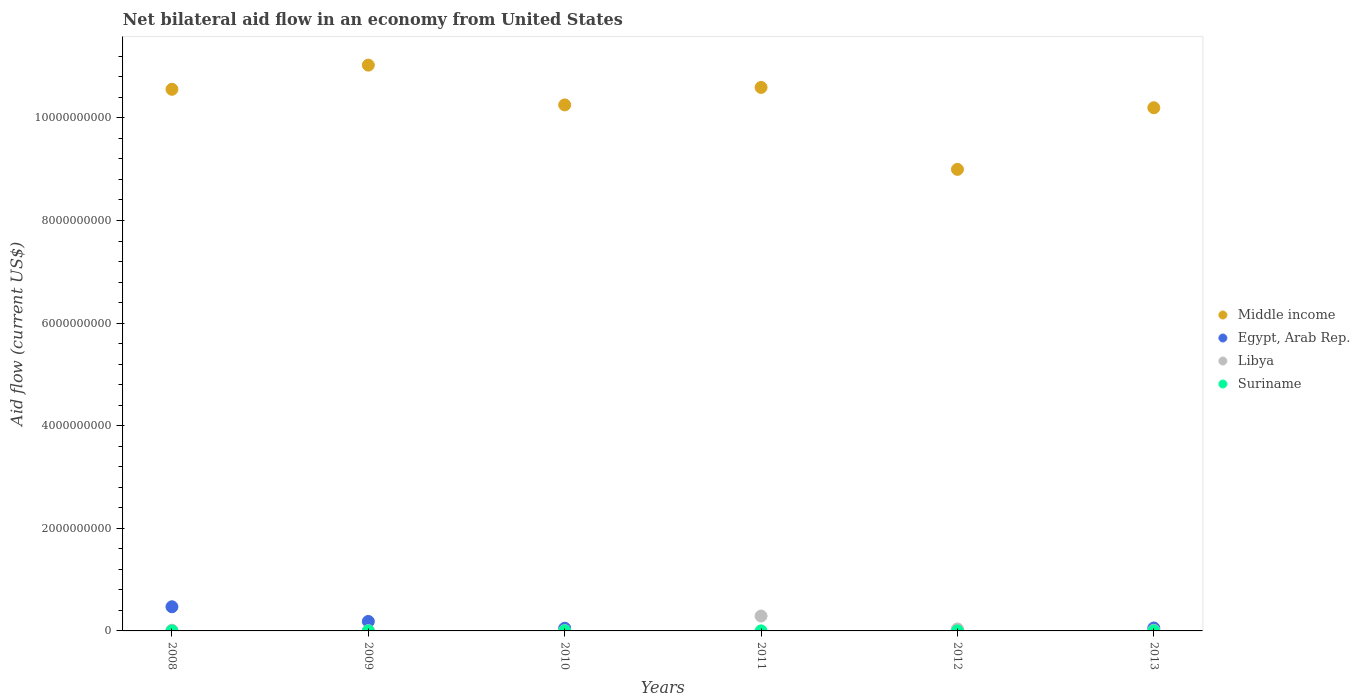How many different coloured dotlines are there?
Offer a very short reply. 4. What is the net bilateral aid flow in Libya in 2010?
Your response must be concise. 6.60e+06. Across all years, what is the maximum net bilateral aid flow in Libya?
Ensure brevity in your answer.  2.90e+08. Across all years, what is the minimum net bilateral aid flow in Libya?
Offer a terse response. 5.65e+06. In which year was the net bilateral aid flow in Middle income maximum?
Your answer should be compact. 2009. What is the total net bilateral aid flow in Suriname in the graph?
Provide a short and direct response. 1.89e+06. What is the difference between the net bilateral aid flow in Libya in 2008 and the net bilateral aid flow in Suriname in 2010?
Offer a terse response. 1.40e+07. What is the average net bilateral aid flow in Egypt, Arab Rep. per year?
Your response must be concise. 1.28e+08. In the year 2010, what is the difference between the net bilateral aid flow in Suriname and net bilateral aid flow in Middle income?
Offer a very short reply. -1.03e+1. In how many years, is the net bilateral aid flow in Suriname greater than 8000000000 US$?
Ensure brevity in your answer.  0. What is the ratio of the net bilateral aid flow in Egypt, Arab Rep. in 2010 to that in 2013?
Make the answer very short. 0.92. What is the difference between the highest and the second highest net bilateral aid flow in Middle income?
Provide a short and direct response. 4.35e+08. What is the difference between the highest and the lowest net bilateral aid flow in Libya?
Ensure brevity in your answer.  2.85e+08. Is it the case that in every year, the sum of the net bilateral aid flow in Libya and net bilateral aid flow in Egypt, Arab Rep.  is greater than the sum of net bilateral aid flow in Suriname and net bilateral aid flow in Middle income?
Offer a very short reply. No. Is it the case that in every year, the sum of the net bilateral aid flow in Suriname and net bilateral aid flow in Egypt, Arab Rep.  is greater than the net bilateral aid flow in Libya?
Offer a very short reply. No. Does the net bilateral aid flow in Suriname monotonically increase over the years?
Offer a terse response. No. Is the net bilateral aid flow in Suriname strictly less than the net bilateral aid flow in Middle income over the years?
Your answer should be very brief. Yes. What is the difference between two consecutive major ticks on the Y-axis?
Keep it short and to the point. 2.00e+09. Are the values on the major ticks of Y-axis written in scientific E-notation?
Make the answer very short. No. Does the graph contain any zero values?
Keep it short and to the point. Yes. Does the graph contain grids?
Make the answer very short. No. Where does the legend appear in the graph?
Your response must be concise. Center right. How are the legend labels stacked?
Make the answer very short. Vertical. What is the title of the graph?
Keep it short and to the point. Net bilateral aid flow in an economy from United States. Does "Middle East & North Africa (developing only)" appear as one of the legend labels in the graph?
Ensure brevity in your answer.  No. What is the label or title of the X-axis?
Provide a short and direct response. Years. What is the label or title of the Y-axis?
Provide a succinct answer. Aid flow (current US$). What is the Aid flow (current US$) in Middle income in 2008?
Offer a very short reply. 1.06e+1. What is the Aid flow (current US$) in Egypt, Arab Rep. in 2008?
Provide a succinct answer. 4.71e+08. What is the Aid flow (current US$) in Libya in 2008?
Provide a succinct answer. 1.43e+07. What is the Aid flow (current US$) of Middle income in 2009?
Your response must be concise. 1.10e+1. What is the Aid flow (current US$) of Egypt, Arab Rep. in 2009?
Provide a short and direct response. 1.85e+08. What is the Aid flow (current US$) of Libya in 2009?
Your answer should be very brief. 5.65e+06. What is the Aid flow (current US$) in Suriname in 2009?
Offer a very short reply. 6.40e+05. What is the Aid flow (current US$) of Middle income in 2010?
Make the answer very short. 1.03e+1. What is the Aid flow (current US$) of Egypt, Arab Rep. in 2010?
Provide a succinct answer. 5.27e+07. What is the Aid flow (current US$) of Libya in 2010?
Keep it short and to the point. 6.60e+06. What is the Aid flow (current US$) of Suriname in 2010?
Ensure brevity in your answer.  2.20e+05. What is the Aid flow (current US$) in Middle income in 2011?
Make the answer very short. 1.06e+1. What is the Aid flow (current US$) of Libya in 2011?
Offer a terse response. 2.90e+08. What is the Aid flow (current US$) of Suriname in 2011?
Make the answer very short. 9.70e+05. What is the Aid flow (current US$) in Middle income in 2012?
Give a very brief answer. 9.00e+09. What is the Aid flow (current US$) of Libya in 2012?
Give a very brief answer. 3.85e+07. What is the Aid flow (current US$) in Suriname in 2012?
Ensure brevity in your answer.  6.00e+04. What is the Aid flow (current US$) in Middle income in 2013?
Make the answer very short. 1.02e+1. What is the Aid flow (current US$) of Egypt, Arab Rep. in 2013?
Offer a very short reply. 5.72e+07. What is the Aid flow (current US$) in Libya in 2013?
Your response must be concise. 1.24e+07. Across all years, what is the maximum Aid flow (current US$) of Middle income?
Your response must be concise. 1.10e+1. Across all years, what is the maximum Aid flow (current US$) in Egypt, Arab Rep.?
Give a very brief answer. 4.71e+08. Across all years, what is the maximum Aid flow (current US$) of Libya?
Give a very brief answer. 2.90e+08. Across all years, what is the maximum Aid flow (current US$) in Suriname?
Make the answer very short. 9.70e+05. Across all years, what is the minimum Aid flow (current US$) in Middle income?
Ensure brevity in your answer.  9.00e+09. Across all years, what is the minimum Aid flow (current US$) in Egypt, Arab Rep.?
Your answer should be very brief. 0. Across all years, what is the minimum Aid flow (current US$) in Libya?
Ensure brevity in your answer.  5.65e+06. What is the total Aid flow (current US$) of Middle income in the graph?
Your response must be concise. 6.16e+1. What is the total Aid flow (current US$) in Egypt, Arab Rep. in the graph?
Your answer should be compact. 7.66e+08. What is the total Aid flow (current US$) of Libya in the graph?
Give a very brief answer. 3.68e+08. What is the total Aid flow (current US$) of Suriname in the graph?
Your response must be concise. 1.89e+06. What is the difference between the Aid flow (current US$) of Middle income in 2008 and that in 2009?
Provide a short and direct response. -4.71e+08. What is the difference between the Aid flow (current US$) of Egypt, Arab Rep. in 2008 and that in 2009?
Make the answer very short. 2.86e+08. What is the difference between the Aid flow (current US$) in Libya in 2008 and that in 2009?
Your response must be concise. 8.61e+06. What is the difference between the Aid flow (current US$) in Middle income in 2008 and that in 2010?
Make the answer very short. 3.04e+08. What is the difference between the Aid flow (current US$) of Egypt, Arab Rep. in 2008 and that in 2010?
Make the answer very short. 4.18e+08. What is the difference between the Aid flow (current US$) of Libya in 2008 and that in 2010?
Give a very brief answer. 7.66e+06. What is the difference between the Aid flow (current US$) in Middle income in 2008 and that in 2011?
Keep it short and to the point. -3.65e+07. What is the difference between the Aid flow (current US$) of Libya in 2008 and that in 2011?
Ensure brevity in your answer.  -2.76e+08. What is the difference between the Aid flow (current US$) in Middle income in 2008 and that in 2012?
Make the answer very short. 1.56e+09. What is the difference between the Aid flow (current US$) in Libya in 2008 and that in 2012?
Provide a succinct answer. -2.43e+07. What is the difference between the Aid flow (current US$) of Middle income in 2008 and that in 2013?
Provide a short and direct response. 3.60e+08. What is the difference between the Aid flow (current US$) of Egypt, Arab Rep. in 2008 and that in 2013?
Your response must be concise. 4.14e+08. What is the difference between the Aid flow (current US$) in Libya in 2008 and that in 2013?
Your answer should be very brief. 1.91e+06. What is the difference between the Aid flow (current US$) of Middle income in 2009 and that in 2010?
Keep it short and to the point. 7.76e+08. What is the difference between the Aid flow (current US$) of Egypt, Arab Rep. in 2009 and that in 2010?
Your response must be concise. 1.32e+08. What is the difference between the Aid flow (current US$) in Libya in 2009 and that in 2010?
Give a very brief answer. -9.50e+05. What is the difference between the Aid flow (current US$) in Suriname in 2009 and that in 2010?
Offer a very short reply. 4.20e+05. What is the difference between the Aid flow (current US$) in Middle income in 2009 and that in 2011?
Give a very brief answer. 4.35e+08. What is the difference between the Aid flow (current US$) of Libya in 2009 and that in 2011?
Offer a very short reply. -2.85e+08. What is the difference between the Aid flow (current US$) of Suriname in 2009 and that in 2011?
Ensure brevity in your answer.  -3.30e+05. What is the difference between the Aid flow (current US$) in Middle income in 2009 and that in 2012?
Give a very brief answer. 2.03e+09. What is the difference between the Aid flow (current US$) of Libya in 2009 and that in 2012?
Your answer should be very brief. -3.29e+07. What is the difference between the Aid flow (current US$) in Suriname in 2009 and that in 2012?
Give a very brief answer. 5.80e+05. What is the difference between the Aid flow (current US$) of Middle income in 2009 and that in 2013?
Make the answer very short. 8.31e+08. What is the difference between the Aid flow (current US$) in Egypt, Arab Rep. in 2009 and that in 2013?
Your answer should be very brief. 1.28e+08. What is the difference between the Aid flow (current US$) of Libya in 2009 and that in 2013?
Ensure brevity in your answer.  -6.70e+06. What is the difference between the Aid flow (current US$) of Middle income in 2010 and that in 2011?
Provide a short and direct response. -3.41e+08. What is the difference between the Aid flow (current US$) of Libya in 2010 and that in 2011?
Your answer should be very brief. -2.84e+08. What is the difference between the Aid flow (current US$) of Suriname in 2010 and that in 2011?
Provide a succinct answer. -7.50e+05. What is the difference between the Aid flow (current US$) of Middle income in 2010 and that in 2012?
Keep it short and to the point. 1.26e+09. What is the difference between the Aid flow (current US$) of Libya in 2010 and that in 2012?
Give a very brief answer. -3.19e+07. What is the difference between the Aid flow (current US$) of Suriname in 2010 and that in 2012?
Give a very brief answer. 1.60e+05. What is the difference between the Aid flow (current US$) in Middle income in 2010 and that in 2013?
Make the answer very short. 5.56e+07. What is the difference between the Aid flow (current US$) of Egypt, Arab Rep. in 2010 and that in 2013?
Provide a succinct answer. -4.54e+06. What is the difference between the Aid flow (current US$) in Libya in 2010 and that in 2013?
Offer a terse response. -5.75e+06. What is the difference between the Aid flow (current US$) of Middle income in 2011 and that in 2012?
Your answer should be very brief. 1.60e+09. What is the difference between the Aid flow (current US$) of Libya in 2011 and that in 2012?
Offer a very short reply. 2.52e+08. What is the difference between the Aid flow (current US$) of Suriname in 2011 and that in 2012?
Keep it short and to the point. 9.10e+05. What is the difference between the Aid flow (current US$) in Middle income in 2011 and that in 2013?
Offer a very short reply. 3.96e+08. What is the difference between the Aid flow (current US$) of Libya in 2011 and that in 2013?
Offer a terse response. 2.78e+08. What is the difference between the Aid flow (current US$) of Middle income in 2012 and that in 2013?
Ensure brevity in your answer.  -1.20e+09. What is the difference between the Aid flow (current US$) of Libya in 2012 and that in 2013?
Keep it short and to the point. 2.62e+07. What is the difference between the Aid flow (current US$) in Middle income in 2008 and the Aid flow (current US$) in Egypt, Arab Rep. in 2009?
Offer a terse response. 1.04e+1. What is the difference between the Aid flow (current US$) of Middle income in 2008 and the Aid flow (current US$) of Libya in 2009?
Ensure brevity in your answer.  1.06e+1. What is the difference between the Aid flow (current US$) of Middle income in 2008 and the Aid flow (current US$) of Suriname in 2009?
Offer a terse response. 1.06e+1. What is the difference between the Aid flow (current US$) of Egypt, Arab Rep. in 2008 and the Aid flow (current US$) of Libya in 2009?
Make the answer very short. 4.65e+08. What is the difference between the Aid flow (current US$) of Egypt, Arab Rep. in 2008 and the Aid flow (current US$) of Suriname in 2009?
Make the answer very short. 4.70e+08. What is the difference between the Aid flow (current US$) in Libya in 2008 and the Aid flow (current US$) in Suriname in 2009?
Give a very brief answer. 1.36e+07. What is the difference between the Aid flow (current US$) of Middle income in 2008 and the Aid flow (current US$) of Egypt, Arab Rep. in 2010?
Your answer should be very brief. 1.05e+1. What is the difference between the Aid flow (current US$) in Middle income in 2008 and the Aid flow (current US$) in Libya in 2010?
Provide a short and direct response. 1.06e+1. What is the difference between the Aid flow (current US$) in Middle income in 2008 and the Aid flow (current US$) in Suriname in 2010?
Offer a terse response. 1.06e+1. What is the difference between the Aid flow (current US$) in Egypt, Arab Rep. in 2008 and the Aid flow (current US$) in Libya in 2010?
Make the answer very short. 4.64e+08. What is the difference between the Aid flow (current US$) in Egypt, Arab Rep. in 2008 and the Aid flow (current US$) in Suriname in 2010?
Your answer should be very brief. 4.71e+08. What is the difference between the Aid flow (current US$) of Libya in 2008 and the Aid flow (current US$) of Suriname in 2010?
Your answer should be very brief. 1.40e+07. What is the difference between the Aid flow (current US$) of Middle income in 2008 and the Aid flow (current US$) of Libya in 2011?
Provide a short and direct response. 1.03e+1. What is the difference between the Aid flow (current US$) of Middle income in 2008 and the Aid flow (current US$) of Suriname in 2011?
Your answer should be very brief. 1.06e+1. What is the difference between the Aid flow (current US$) of Egypt, Arab Rep. in 2008 and the Aid flow (current US$) of Libya in 2011?
Ensure brevity in your answer.  1.81e+08. What is the difference between the Aid flow (current US$) of Egypt, Arab Rep. in 2008 and the Aid flow (current US$) of Suriname in 2011?
Ensure brevity in your answer.  4.70e+08. What is the difference between the Aid flow (current US$) of Libya in 2008 and the Aid flow (current US$) of Suriname in 2011?
Keep it short and to the point. 1.33e+07. What is the difference between the Aid flow (current US$) in Middle income in 2008 and the Aid flow (current US$) in Libya in 2012?
Keep it short and to the point. 1.05e+1. What is the difference between the Aid flow (current US$) of Middle income in 2008 and the Aid flow (current US$) of Suriname in 2012?
Your answer should be very brief. 1.06e+1. What is the difference between the Aid flow (current US$) of Egypt, Arab Rep. in 2008 and the Aid flow (current US$) of Libya in 2012?
Give a very brief answer. 4.32e+08. What is the difference between the Aid flow (current US$) of Egypt, Arab Rep. in 2008 and the Aid flow (current US$) of Suriname in 2012?
Provide a short and direct response. 4.71e+08. What is the difference between the Aid flow (current US$) of Libya in 2008 and the Aid flow (current US$) of Suriname in 2012?
Keep it short and to the point. 1.42e+07. What is the difference between the Aid flow (current US$) of Middle income in 2008 and the Aid flow (current US$) of Egypt, Arab Rep. in 2013?
Make the answer very short. 1.05e+1. What is the difference between the Aid flow (current US$) in Middle income in 2008 and the Aid flow (current US$) in Libya in 2013?
Give a very brief answer. 1.05e+1. What is the difference between the Aid flow (current US$) in Egypt, Arab Rep. in 2008 and the Aid flow (current US$) in Libya in 2013?
Make the answer very short. 4.58e+08. What is the difference between the Aid flow (current US$) of Middle income in 2009 and the Aid flow (current US$) of Egypt, Arab Rep. in 2010?
Make the answer very short. 1.10e+1. What is the difference between the Aid flow (current US$) of Middle income in 2009 and the Aid flow (current US$) of Libya in 2010?
Ensure brevity in your answer.  1.10e+1. What is the difference between the Aid flow (current US$) in Middle income in 2009 and the Aid flow (current US$) in Suriname in 2010?
Ensure brevity in your answer.  1.10e+1. What is the difference between the Aid flow (current US$) in Egypt, Arab Rep. in 2009 and the Aid flow (current US$) in Libya in 2010?
Make the answer very short. 1.78e+08. What is the difference between the Aid flow (current US$) of Egypt, Arab Rep. in 2009 and the Aid flow (current US$) of Suriname in 2010?
Your response must be concise. 1.85e+08. What is the difference between the Aid flow (current US$) in Libya in 2009 and the Aid flow (current US$) in Suriname in 2010?
Make the answer very short. 5.43e+06. What is the difference between the Aid flow (current US$) of Middle income in 2009 and the Aid flow (current US$) of Libya in 2011?
Your response must be concise. 1.07e+1. What is the difference between the Aid flow (current US$) of Middle income in 2009 and the Aid flow (current US$) of Suriname in 2011?
Your response must be concise. 1.10e+1. What is the difference between the Aid flow (current US$) in Egypt, Arab Rep. in 2009 and the Aid flow (current US$) in Libya in 2011?
Offer a terse response. -1.05e+08. What is the difference between the Aid flow (current US$) in Egypt, Arab Rep. in 2009 and the Aid flow (current US$) in Suriname in 2011?
Ensure brevity in your answer.  1.84e+08. What is the difference between the Aid flow (current US$) of Libya in 2009 and the Aid flow (current US$) of Suriname in 2011?
Give a very brief answer. 4.68e+06. What is the difference between the Aid flow (current US$) of Middle income in 2009 and the Aid flow (current US$) of Libya in 2012?
Your answer should be very brief. 1.10e+1. What is the difference between the Aid flow (current US$) in Middle income in 2009 and the Aid flow (current US$) in Suriname in 2012?
Keep it short and to the point. 1.10e+1. What is the difference between the Aid flow (current US$) of Egypt, Arab Rep. in 2009 and the Aid flow (current US$) of Libya in 2012?
Offer a very short reply. 1.47e+08. What is the difference between the Aid flow (current US$) in Egypt, Arab Rep. in 2009 and the Aid flow (current US$) in Suriname in 2012?
Your answer should be compact. 1.85e+08. What is the difference between the Aid flow (current US$) of Libya in 2009 and the Aid flow (current US$) of Suriname in 2012?
Keep it short and to the point. 5.59e+06. What is the difference between the Aid flow (current US$) in Middle income in 2009 and the Aid flow (current US$) in Egypt, Arab Rep. in 2013?
Your answer should be compact. 1.10e+1. What is the difference between the Aid flow (current US$) of Middle income in 2009 and the Aid flow (current US$) of Libya in 2013?
Offer a terse response. 1.10e+1. What is the difference between the Aid flow (current US$) of Egypt, Arab Rep. in 2009 and the Aid flow (current US$) of Libya in 2013?
Keep it short and to the point. 1.73e+08. What is the difference between the Aid flow (current US$) of Middle income in 2010 and the Aid flow (current US$) of Libya in 2011?
Give a very brief answer. 9.96e+09. What is the difference between the Aid flow (current US$) in Middle income in 2010 and the Aid flow (current US$) in Suriname in 2011?
Offer a terse response. 1.03e+1. What is the difference between the Aid flow (current US$) in Egypt, Arab Rep. in 2010 and the Aid flow (current US$) in Libya in 2011?
Offer a very short reply. -2.38e+08. What is the difference between the Aid flow (current US$) of Egypt, Arab Rep. in 2010 and the Aid flow (current US$) of Suriname in 2011?
Ensure brevity in your answer.  5.17e+07. What is the difference between the Aid flow (current US$) in Libya in 2010 and the Aid flow (current US$) in Suriname in 2011?
Provide a short and direct response. 5.63e+06. What is the difference between the Aid flow (current US$) in Middle income in 2010 and the Aid flow (current US$) in Libya in 2012?
Provide a short and direct response. 1.02e+1. What is the difference between the Aid flow (current US$) of Middle income in 2010 and the Aid flow (current US$) of Suriname in 2012?
Your answer should be very brief. 1.03e+1. What is the difference between the Aid flow (current US$) in Egypt, Arab Rep. in 2010 and the Aid flow (current US$) in Libya in 2012?
Give a very brief answer. 1.41e+07. What is the difference between the Aid flow (current US$) in Egypt, Arab Rep. in 2010 and the Aid flow (current US$) in Suriname in 2012?
Your answer should be compact. 5.26e+07. What is the difference between the Aid flow (current US$) in Libya in 2010 and the Aid flow (current US$) in Suriname in 2012?
Provide a short and direct response. 6.54e+06. What is the difference between the Aid flow (current US$) of Middle income in 2010 and the Aid flow (current US$) of Egypt, Arab Rep. in 2013?
Ensure brevity in your answer.  1.02e+1. What is the difference between the Aid flow (current US$) in Middle income in 2010 and the Aid flow (current US$) in Libya in 2013?
Offer a terse response. 1.02e+1. What is the difference between the Aid flow (current US$) in Egypt, Arab Rep. in 2010 and the Aid flow (current US$) in Libya in 2013?
Your response must be concise. 4.03e+07. What is the difference between the Aid flow (current US$) in Middle income in 2011 and the Aid flow (current US$) in Libya in 2012?
Give a very brief answer. 1.06e+1. What is the difference between the Aid flow (current US$) in Middle income in 2011 and the Aid flow (current US$) in Suriname in 2012?
Your answer should be very brief. 1.06e+1. What is the difference between the Aid flow (current US$) in Libya in 2011 and the Aid flow (current US$) in Suriname in 2012?
Keep it short and to the point. 2.90e+08. What is the difference between the Aid flow (current US$) of Middle income in 2011 and the Aid flow (current US$) of Egypt, Arab Rep. in 2013?
Give a very brief answer. 1.05e+1. What is the difference between the Aid flow (current US$) of Middle income in 2011 and the Aid flow (current US$) of Libya in 2013?
Give a very brief answer. 1.06e+1. What is the difference between the Aid flow (current US$) in Middle income in 2012 and the Aid flow (current US$) in Egypt, Arab Rep. in 2013?
Provide a short and direct response. 8.94e+09. What is the difference between the Aid flow (current US$) of Middle income in 2012 and the Aid flow (current US$) of Libya in 2013?
Make the answer very short. 8.98e+09. What is the average Aid flow (current US$) of Middle income per year?
Your answer should be compact. 1.03e+1. What is the average Aid flow (current US$) of Egypt, Arab Rep. per year?
Your answer should be compact. 1.28e+08. What is the average Aid flow (current US$) of Libya per year?
Your answer should be compact. 6.13e+07. What is the average Aid flow (current US$) in Suriname per year?
Your response must be concise. 3.15e+05. In the year 2008, what is the difference between the Aid flow (current US$) in Middle income and Aid flow (current US$) in Egypt, Arab Rep.?
Your answer should be very brief. 1.01e+1. In the year 2008, what is the difference between the Aid flow (current US$) in Middle income and Aid flow (current US$) in Libya?
Offer a terse response. 1.05e+1. In the year 2008, what is the difference between the Aid flow (current US$) in Egypt, Arab Rep. and Aid flow (current US$) in Libya?
Give a very brief answer. 4.57e+08. In the year 2009, what is the difference between the Aid flow (current US$) of Middle income and Aid flow (current US$) of Egypt, Arab Rep.?
Provide a short and direct response. 1.08e+1. In the year 2009, what is the difference between the Aid flow (current US$) in Middle income and Aid flow (current US$) in Libya?
Provide a succinct answer. 1.10e+1. In the year 2009, what is the difference between the Aid flow (current US$) in Middle income and Aid flow (current US$) in Suriname?
Make the answer very short. 1.10e+1. In the year 2009, what is the difference between the Aid flow (current US$) in Egypt, Arab Rep. and Aid flow (current US$) in Libya?
Ensure brevity in your answer.  1.79e+08. In the year 2009, what is the difference between the Aid flow (current US$) of Egypt, Arab Rep. and Aid flow (current US$) of Suriname?
Your answer should be compact. 1.84e+08. In the year 2009, what is the difference between the Aid flow (current US$) in Libya and Aid flow (current US$) in Suriname?
Provide a succinct answer. 5.01e+06. In the year 2010, what is the difference between the Aid flow (current US$) of Middle income and Aid flow (current US$) of Egypt, Arab Rep.?
Your answer should be compact. 1.02e+1. In the year 2010, what is the difference between the Aid flow (current US$) in Middle income and Aid flow (current US$) in Libya?
Make the answer very short. 1.02e+1. In the year 2010, what is the difference between the Aid flow (current US$) in Middle income and Aid flow (current US$) in Suriname?
Offer a terse response. 1.03e+1. In the year 2010, what is the difference between the Aid flow (current US$) in Egypt, Arab Rep. and Aid flow (current US$) in Libya?
Your answer should be very brief. 4.61e+07. In the year 2010, what is the difference between the Aid flow (current US$) of Egypt, Arab Rep. and Aid flow (current US$) of Suriname?
Give a very brief answer. 5.24e+07. In the year 2010, what is the difference between the Aid flow (current US$) of Libya and Aid flow (current US$) of Suriname?
Make the answer very short. 6.38e+06. In the year 2011, what is the difference between the Aid flow (current US$) in Middle income and Aid flow (current US$) in Libya?
Keep it short and to the point. 1.03e+1. In the year 2011, what is the difference between the Aid flow (current US$) in Middle income and Aid flow (current US$) in Suriname?
Offer a terse response. 1.06e+1. In the year 2011, what is the difference between the Aid flow (current US$) in Libya and Aid flow (current US$) in Suriname?
Your answer should be compact. 2.89e+08. In the year 2012, what is the difference between the Aid flow (current US$) of Middle income and Aid flow (current US$) of Libya?
Provide a short and direct response. 8.96e+09. In the year 2012, what is the difference between the Aid flow (current US$) in Middle income and Aid flow (current US$) in Suriname?
Your response must be concise. 9.00e+09. In the year 2012, what is the difference between the Aid flow (current US$) in Libya and Aid flow (current US$) in Suriname?
Offer a terse response. 3.85e+07. In the year 2013, what is the difference between the Aid flow (current US$) of Middle income and Aid flow (current US$) of Egypt, Arab Rep.?
Offer a very short reply. 1.01e+1. In the year 2013, what is the difference between the Aid flow (current US$) in Middle income and Aid flow (current US$) in Libya?
Offer a very short reply. 1.02e+1. In the year 2013, what is the difference between the Aid flow (current US$) of Egypt, Arab Rep. and Aid flow (current US$) of Libya?
Your response must be concise. 4.48e+07. What is the ratio of the Aid flow (current US$) in Middle income in 2008 to that in 2009?
Keep it short and to the point. 0.96. What is the ratio of the Aid flow (current US$) of Egypt, Arab Rep. in 2008 to that in 2009?
Offer a very short reply. 2.54. What is the ratio of the Aid flow (current US$) in Libya in 2008 to that in 2009?
Your answer should be compact. 2.52. What is the ratio of the Aid flow (current US$) in Middle income in 2008 to that in 2010?
Keep it short and to the point. 1.03. What is the ratio of the Aid flow (current US$) of Egypt, Arab Rep. in 2008 to that in 2010?
Make the answer very short. 8.94. What is the ratio of the Aid flow (current US$) of Libya in 2008 to that in 2010?
Ensure brevity in your answer.  2.16. What is the ratio of the Aid flow (current US$) in Libya in 2008 to that in 2011?
Ensure brevity in your answer.  0.05. What is the ratio of the Aid flow (current US$) of Middle income in 2008 to that in 2012?
Provide a short and direct response. 1.17. What is the ratio of the Aid flow (current US$) of Libya in 2008 to that in 2012?
Make the answer very short. 0.37. What is the ratio of the Aid flow (current US$) in Middle income in 2008 to that in 2013?
Offer a very short reply. 1.04. What is the ratio of the Aid flow (current US$) in Egypt, Arab Rep. in 2008 to that in 2013?
Make the answer very short. 8.23. What is the ratio of the Aid flow (current US$) in Libya in 2008 to that in 2013?
Your answer should be very brief. 1.15. What is the ratio of the Aid flow (current US$) of Middle income in 2009 to that in 2010?
Keep it short and to the point. 1.08. What is the ratio of the Aid flow (current US$) of Egypt, Arab Rep. in 2009 to that in 2010?
Your answer should be compact. 3.51. What is the ratio of the Aid flow (current US$) in Libya in 2009 to that in 2010?
Offer a very short reply. 0.86. What is the ratio of the Aid flow (current US$) of Suriname in 2009 to that in 2010?
Your response must be concise. 2.91. What is the ratio of the Aid flow (current US$) in Middle income in 2009 to that in 2011?
Give a very brief answer. 1.04. What is the ratio of the Aid flow (current US$) in Libya in 2009 to that in 2011?
Offer a terse response. 0.02. What is the ratio of the Aid flow (current US$) in Suriname in 2009 to that in 2011?
Your answer should be very brief. 0.66. What is the ratio of the Aid flow (current US$) of Middle income in 2009 to that in 2012?
Your answer should be very brief. 1.23. What is the ratio of the Aid flow (current US$) of Libya in 2009 to that in 2012?
Ensure brevity in your answer.  0.15. What is the ratio of the Aid flow (current US$) in Suriname in 2009 to that in 2012?
Offer a terse response. 10.67. What is the ratio of the Aid flow (current US$) of Middle income in 2009 to that in 2013?
Ensure brevity in your answer.  1.08. What is the ratio of the Aid flow (current US$) in Egypt, Arab Rep. in 2009 to that in 2013?
Ensure brevity in your answer.  3.24. What is the ratio of the Aid flow (current US$) of Libya in 2009 to that in 2013?
Give a very brief answer. 0.46. What is the ratio of the Aid flow (current US$) in Middle income in 2010 to that in 2011?
Your answer should be compact. 0.97. What is the ratio of the Aid flow (current US$) in Libya in 2010 to that in 2011?
Provide a short and direct response. 0.02. What is the ratio of the Aid flow (current US$) in Suriname in 2010 to that in 2011?
Ensure brevity in your answer.  0.23. What is the ratio of the Aid flow (current US$) of Middle income in 2010 to that in 2012?
Your answer should be very brief. 1.14. What is the ratio of the Aid flow (current US$) of Libya in 2010 to that in 2012?
Give a very brief answer. 0.17. What is the ratio of the Aid flow (current US$) in Suriname in 2010 to that in 2012?
Give a very brief answer. 3.67. What is the ratio of the Aid flow (current US$) in Middle income in 2010 to that in 2013?
Provide a succinct answer. 1.01. What is the ratio of the Aid flow (current US$) in Egypt, Arab Rep. in 2010 to that in 2013?
Keep it short and to the point. 0.92. What is the ratio of the Aid flow (current US$) of Libya in 2010 to that in 2013?
Your response must be concise. 0.53. What is the ratio of the Aid flow (current US$) of Middle income in 2011 to that in 2012?
Provide a succinct answer. 1.18. What is the ratio of the Aid flow (current US$) of Libya in 2011 to that in 2012?
Ensure brevity in your answer.  7.53. What is the ratio of the Aid flow (current US$) of Suriname in 2011 to that in 2012?
Offer a very short reply. 16.17. What is the ratio of the Aid flow (current US$) of Middle income in 2011 to that in 2013?
Your response must be concise. 1.04. What is the ratio of the Aid flow (current US$) of Libya in 2011 to that in 2013?
Keep it short and to the point. 23.5. What is the ratio of the Aid flow (current US$) of Middle income in 2012 to that in 2013?
Offer a very short reply. 0.88. What is the ratio of the Aid flow (current US$) of Libya in 2012 to that in 2013?
Keep it short and to the point. 3.12. What is the difference between the highest and the second highest Aid flow (current US$) in Middle income?
Ensure brevity in your answer.  4.35e+08. What is the difference between the highest and the second highest Aid flow (current US$) in Egypt, Arab Rep.?
Make the answer very short. 2.86e+08. What is the difference between the highest and the second highest Aid flow (current US$) of Libya?
Your answer should be compact. 2.52e+08. What is the difference between the highest and the lowest Aid flow (current US$) in Middle income?
Provide a short and direct response. 2.03e+09. What is the difference between the highest and the lowest Aid flow (current US$) of Egypt, Arab Rep.?
Offer a terse response. 4.71e+08. What is the difference between the highest and the lowest Aid flow (current US$) of Libya?
Keep it short and to the point. 2.85e+08. What is the difference between the highest and the lowest Aid flow (current US$) in Suriname?
Your answer should be very brief. 9.70e+05. 